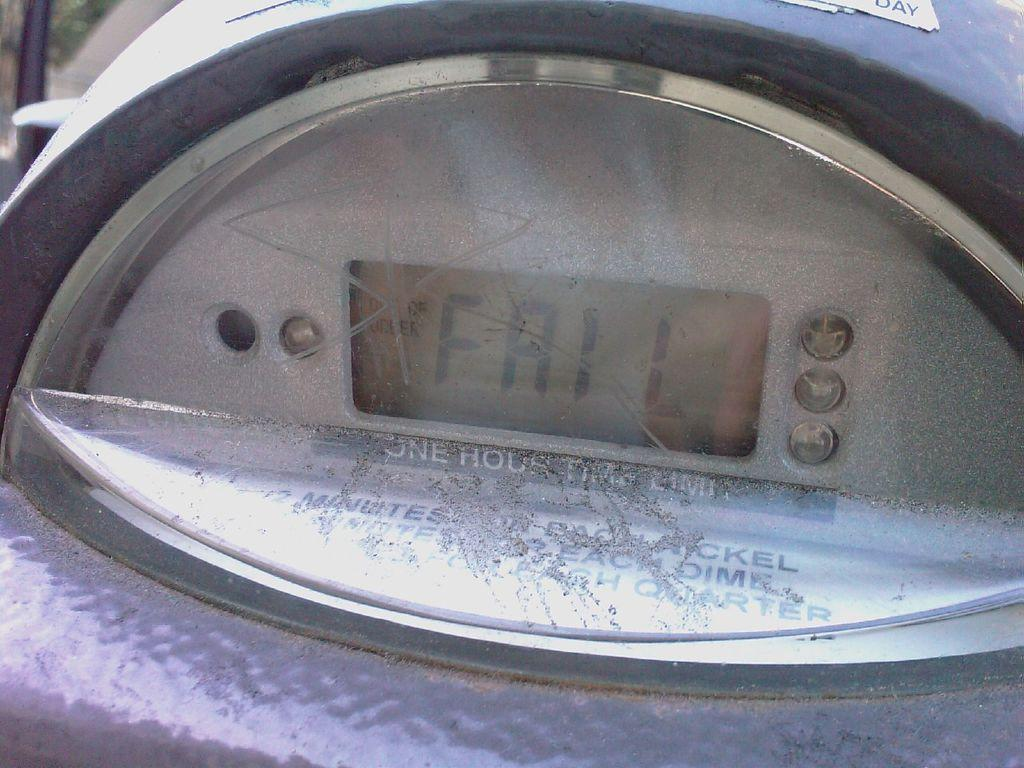Provide a one-sentence caption for the provided image. A digital screen shows the word fail on the screen. 